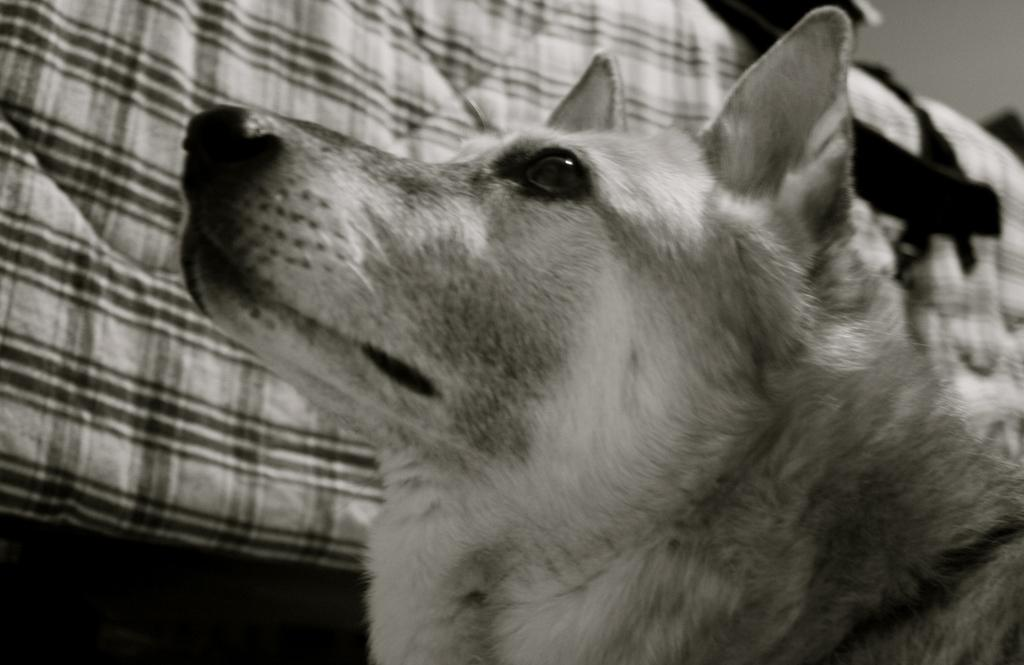What is the color scheme of the image? The image is black and white. What animal can be seen in the image? There is a dog in the image. What is present in the background of the image? There is a cloth in the background of the image. What type of stocking is the dog wearing in the image? There is no stocking present on the dog in the image, as it is a black and white image and stockings are typically not visible in such images. 